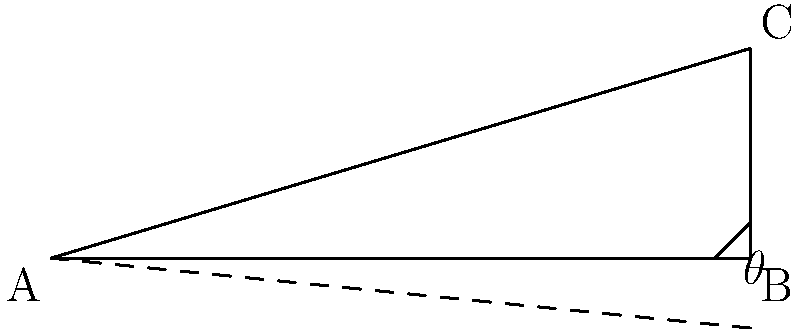The roof of the old Fisherman's Lodge near The Ship pub has a unique slope that's been a topic of discussion among locals. If the base of the roof is 10 meters wide and the peak is 3 meters above the base, what is the angle $\theta$ that the roof makes with the ground? Round your answer to the nearest degree. To find the angle $\theta$ that the roof makes with the ground, we can use trigonometry. Let's approach this step-by-step:

1) In the right triangle formed by the roof and its base, we know:
   - The base (adjacent side) is 10 meters
   - The height (opposite side) is 3 meters

2) We need to find the angle $\theta$. The tangent function relates the opposite and adjacent sides:

   $\tan(\theta) = \frac{\text{opposite}}{\text{adjacent}} = \frac{\text{height}}{\text{base}}$

3) Substituting our known values:

   $\tan(\theta) = \frac{3}{10} = 0.3$

4) To find $\theta$, we need to use the inverse tangent (arctan) function:

   $\theta = \arctan(0.3)$

5) Using a calculator or computer:

   $\theta \approx 16.70^\circ$

6) Rounding to the nearest degree:

   $\theta \approx 17^\circ$

Therefore, the angle that the roof makes with the ground is approximately 17 degrees.
Answer: $17^\circ$ 